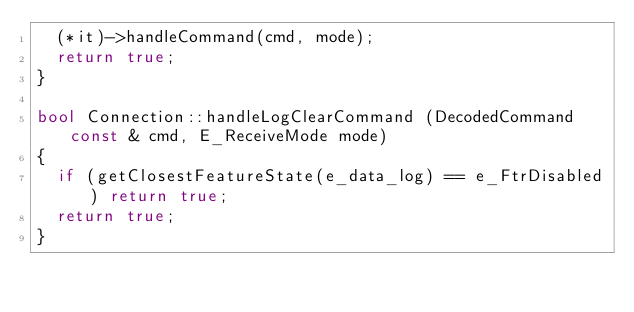Convert code to text. <code><loc_0><loc_0><loc_500><loc_500><_C++_>	(*it)->handleCommand(cmd, mode);
	return true;
}

bool Connection::handleLogClearCommand (DecodedCommand const & cmd, E_ReceiveMode mode)
{
	if (getClosestFeatureState(e_data_log) == e_FtrDisabled) return true;
	return true;
}

</code> 